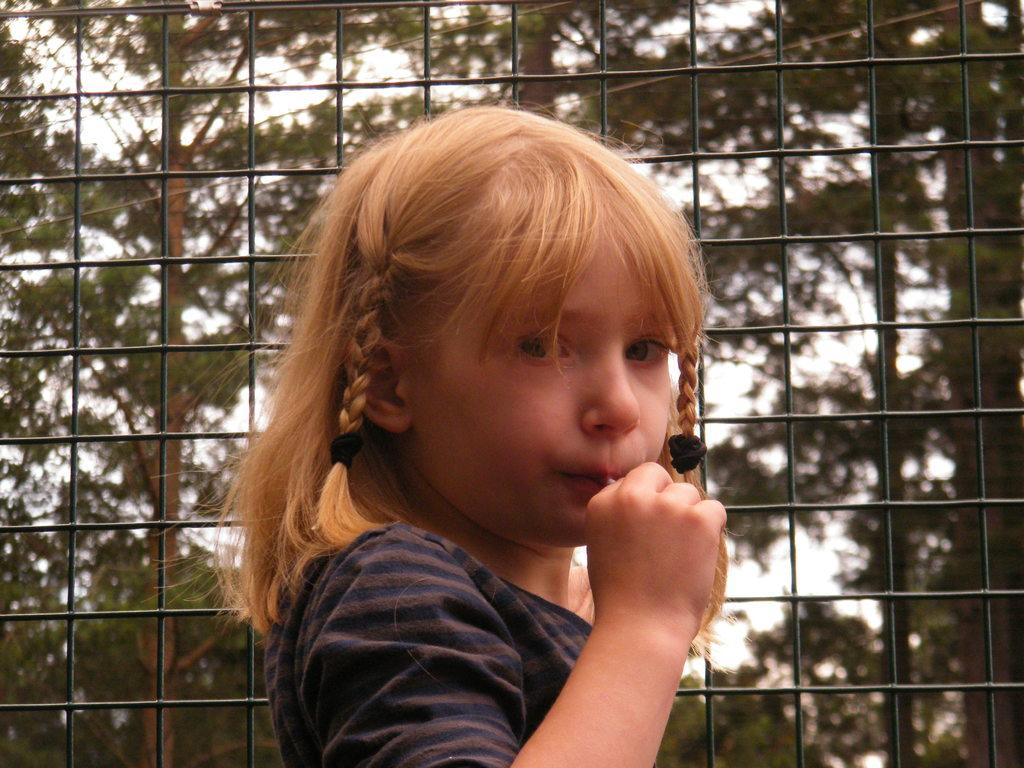Who is the main subject in the image? There is a small girl in the center of the image. What can be seen in the background of the image? There are trees and a net in the background of the image. What type of feather can be seen on the girl's slip in the image? There is no feather or slip present on the girl in the image. What sound does the girl make when she rings the bells in the image? There are no bells present in the image for the girl to ring. 